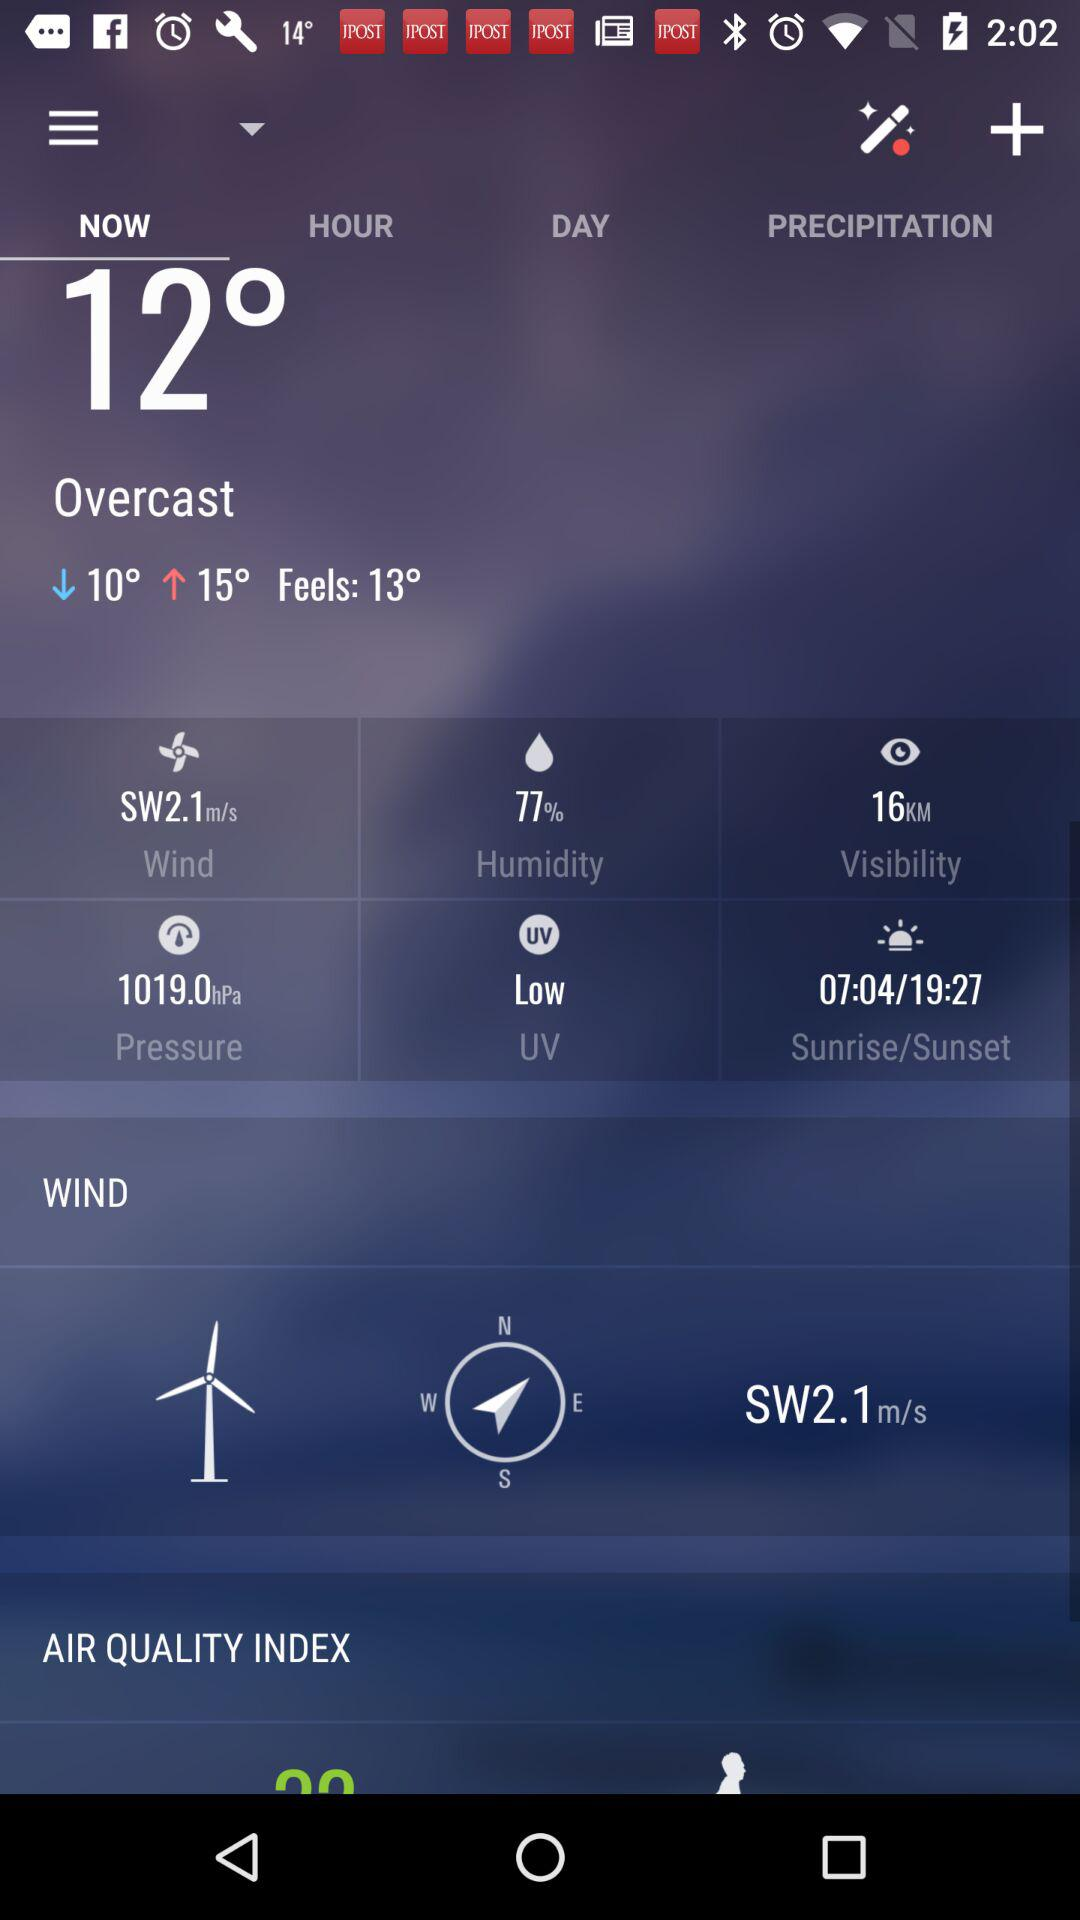How much higher is the high temperature than the low temperature?
Answer the question using a single word or phrase. 5 